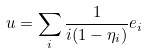Convert formula to latex. <formula><loc_0><loc_0><loc_500><loc_500>u = \sum _ { i } \frac { 1 } { i ( 1 - \eta _ { i } ) } e _ { i }</formula> 